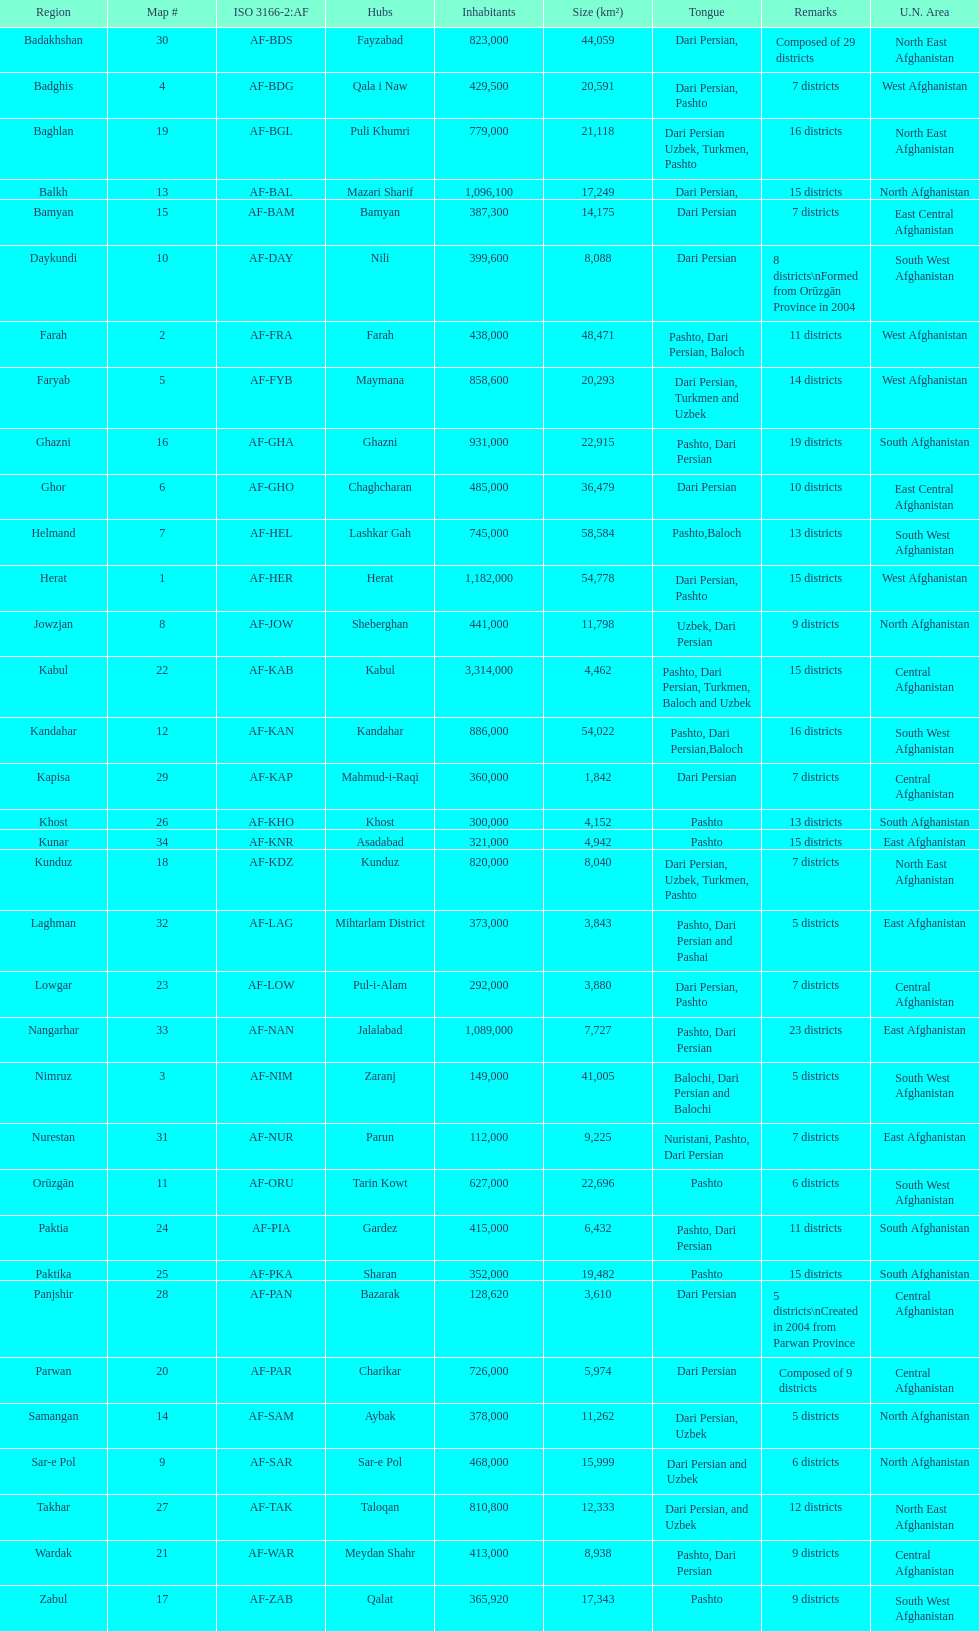Parse the table in full. {'header': ['Region', 'Map #', 'ISO 3166-2:AF', 'Hubs', 'Inhabitants', 'Size (km²)', 'Tongue', 'Remarks', 'U.N. Area'], 'rows': [['Badakhshan', '30', 'AF-BDS', 'Fayzabad', '823,000', '44,059', 'Dari Persian,', 'Composed of 29 districts', 'North East Afghanistan'], ['Badghis', '4', 'AF-BDG', 'Qala i Naw', '429,500', '20,591', 'Dari Persian, Pashto', '7 districts', 'West Afghanistan'], ['Baghlan', '19', 'AF-BGL', 'Puli Khumri', '779,000', '21,118', 'Dari Persian Uzbek, Turkmen, Pashto', '16 districts', 'North East Afghanistan'], ['Balkh', '13', 'AF-BAL', 'Mazari Sharif', '1,096,100', '17,249', 'Dari Persian,', '15 districts', 'North Afghanistan'], ['Bamyan', '15', 'AF-BAM', 'Bamyan', '387,300', '14,175', 'Dari Persian', '7 districts', 'East Central Afghanistan'], ['Daykundi', '10', 'AF-DAY', 'Nili', '399,600', '8,088', 'Dari Persian', '8 districts\\nFormed from Orūzgān Province in 2004', 'South West Afghanistan'], ['Farah', '2', 'AF-FRA', 'Farah', '438,000', '48,471', 'Pashto, Dari Persian, Baloch', '11 districts', 'West Afghanistan'], ['Faryab', '5', 'AF-FYB', 'Maymana', '858,600', '20,293', 'Dari Persian, Turkmen and Uzbek', '14 districts', 'West Afghanistan'], ['Ghazni', '16', 'AF-GHA', 'Ghazni', '931,000', '22,915', 'Pashto, Dari Persian', '19 districts', 'South Afghanistan'], ['Ghor', '6', 'AF-GHO', 'Chaghcharan', '485,000', '36,479', 'Dari Persian', '10 districts', 'East Central Afghanistan'], ['Helmand', '7', 'AF-HEL', 'Lashkar Gah', '745,000', '58,584', 'Pashto,Baloch', '13 districts', 'South West Afghanistan'], ['Herat', '1', 'AF-HER', 'Herat', '1,182,000', '54,778', 'Dari Persian, Pashto', '15 districts', 'West Afghanistan'], ['Jowzjan', '8', 'AF-JOW', 'Sheberghan', '441,000', '11,798', 'Uzbek, Dari Persian', '9 districts', 'North Afghanistan'], ['Kabul', '22', 'AF-KAB', 'Kabul', '3,314,000', '4,462', 'Pashto, Dari Persian, Turkmen, Baloch and Uzbek', '15 districts', 'Central Afghanistan'], ['Kandahar', '12', 'AF-KAN', 'Kandahar', '886,000', '54,022', 'Pashto, Dari Persian,Baloch', '16 districts', 'South West Afghanistan'], ['Kapisa', '29', 'AF-KAP', 'Mahmud-i-Raqi', '360,000', '1,842', 'Dari Persian', '7 districts', 'Central Afghanistan'], ['Khost', '26', 'AF-KHO', 'Khost', '300,000', '4,152', 'Pashto', '13 districts', 'South Afghanistan'], ['Kunar', '34', 'AF-KNR', 'Asadabad', '321,000', '4,942', 'Pashto', '15 districts', 'East Afghanistan'], ['Kunduz', '18', 'AF-KDZ', 'Kunduz', '820,000', '8,040', 'Dari Persian, Uzbek, Turkmen, Pashto', '7 districts', 'North East Afghanistan'], ['Laghman', '32', 'AF-LAG', 'Mihtarlam District', '373,000', '3,843', 'Pashto, Dari Persian and Pashai', '5 districts', 'East Afghanistan'], ['Lowgar', '23', 'AF-LOW', 'Pul-i-Alam', '292,000', '3,880', 'Dari Persian, Pashto', '7 districts', 'Central Afghanistan'], ['Nangarhar', '33', 'AF-NAN', 'Jalalabad', '1,089,000', '7,727', 'Pashto, Dari Persian', '23 districts', 'East Afghanistan'], ['Nimruz', '3', 'AF-NIM', 'Zaranj', '149,000', '41,005', 'Balochi, Dari Persian and Balochi', '5 districts', 'South West Afghanistan'], ['Nurestan', '31', 'AF-NUR', 'Parun', '112,000', '9,225', 'Nuristani, Pashto, Dari Persian', '7 districts', 'East Afghanistan'], ['Orūzgān', '11', 'AF-ORU', 'Tarin Kowt', '627,000', '22,696', 'Pashto', '6 districts', 'South West Afghanistan'], ['Paktia', '24', 'AF-PIA', 'Gardez', '415,000', '6,432', 'Pashto, Dari Persian', '11 districts', 'South Afghanistan'], ['Paktika', '25', 'AF-PKA', 'Sharan', '352,000', '19,482', 'Pashto', '15 districts', 'South Afghanistan'], ['Panjshir', '28', 'AF-PAN', 'Bazarak', '128,620', '3,610', 'Dari Persian', '5 districts\\nCreated in 2004 from Parwan Province', 'Central Afghanistan'], ['Parwan', '20', 'AF-PAR', 'Charikar', '726,000', '5,974', 'Dari Persian', 'Composed of 9 districts', 'Central Afghanistan'], ['Samangan', '14', 'AF-SAM', 'Aybak', '378,000', '11,262', 'Dari Persian, Uzbek', '5 districts', 'North Afghanistan'], ['Sar-e Pol', '9', 'AF-SAR', 'Sar-e Pol', '468,000', '15,999', 'Dari Persian and Uzbek', '6 districts', 'North Afghanistan'], ['Takhar', '27', 'AF-TAK', 'Taloqan', '810,800', '12,333', 'Dari Persian, and Uzbek', '12 districts', 'North East Afghanistan'], ['Wardak', '21', 'AF-WAR', 'Meydan Shahr', '413,000', '8,938', 'Pashto, Dari Persian', '9 districts', 'Central Afghanistan'], ['Zabul', '17', 'AF-ZAB', 'Qalat', '365,920', '17,343', 'Pashto', '9 districts', 'South West Afghanistan']]} In which provinces can pashto be found as a spoken language? 20. 